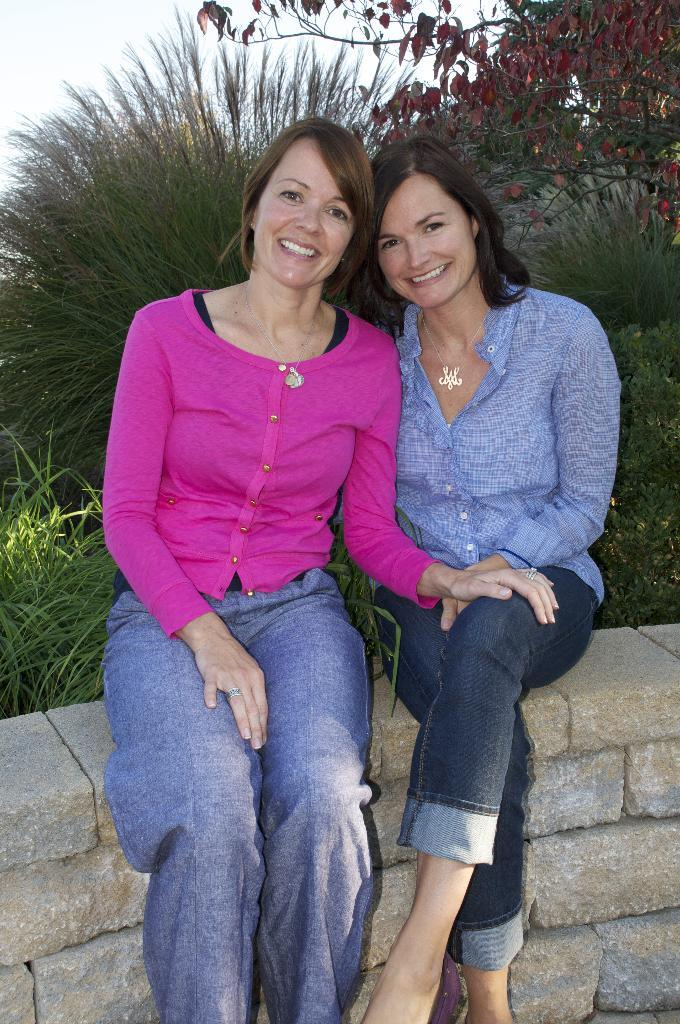How many women are in the image? There are two women in the image. What are the women doing in the image? The women are smiling in the image. Where are the women sitting in the image? The women are sitting on a rock wall in the image. What can be seen in the background of the image? There are plants, trees, and the sky visible in the background of the image. What type of wire can be seen connecting the women's ears in the image? There is no wire connecting the women's ears in the image; they are simply smiling and sitting on a rock wall. 